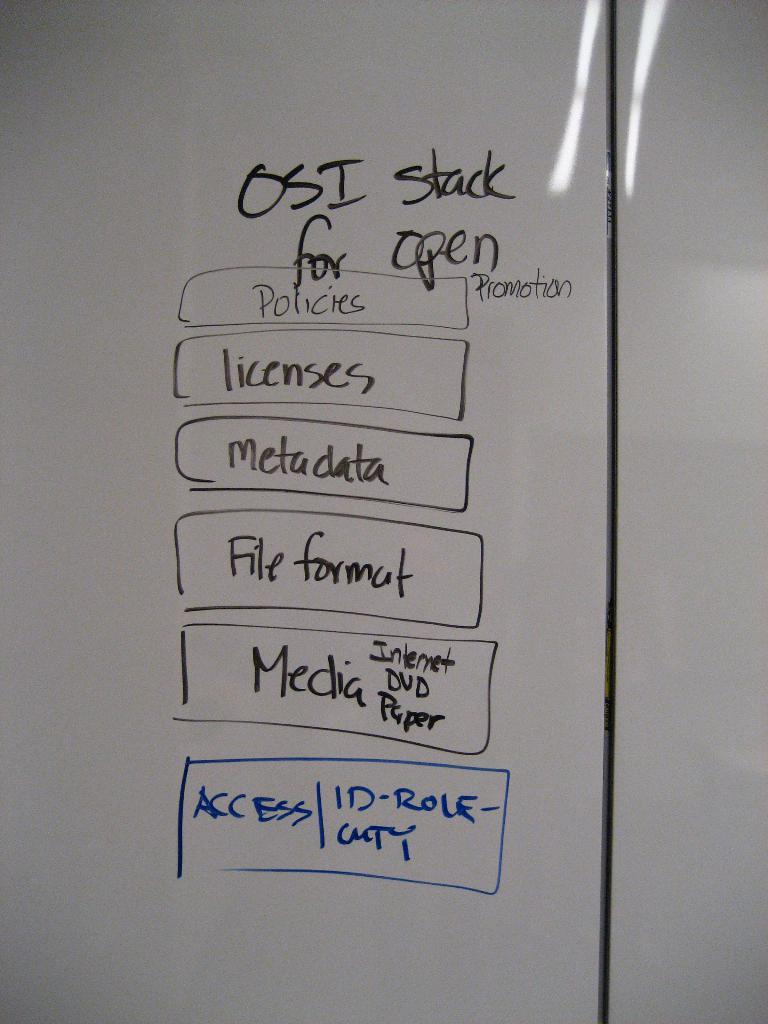<image>
Provide a brief description of the given image. White board that has a box that says ACCESS in blue. 